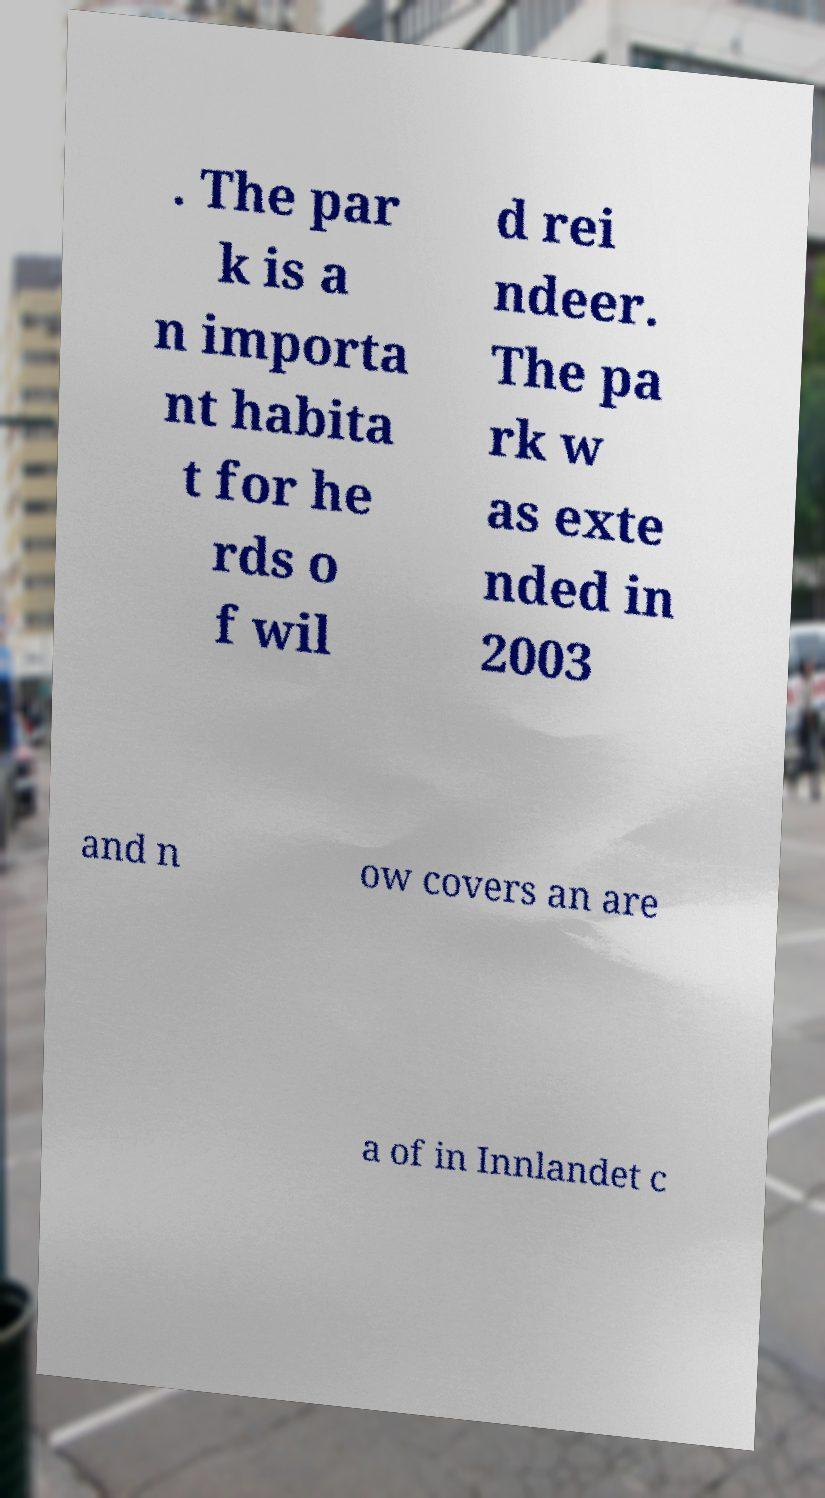Could you assist in decoding the text presented in this image and type it out clearly? . The par k is a n importa nt habita t for he rds o f wil d rei ndeer. The pa rk w as exte nded in 2003 and n ow covers an are a of in Innlandet c 